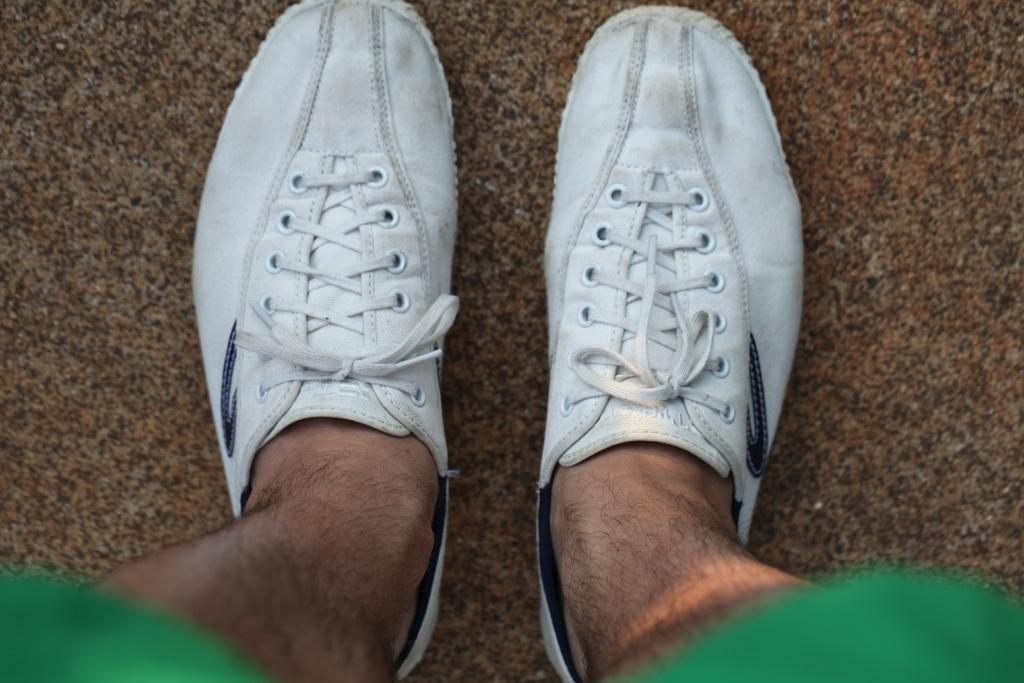What body parts are visible in the image? There are person's legs visible in the image. What type of footwear is the person wearing? The person is wearing shoes. On what surface are the legs resting? The legs are on a surface. Is the person stuck in quicksand in the image? There is no indication of quicksand in the image, and the person's legs are resting on a surface. 